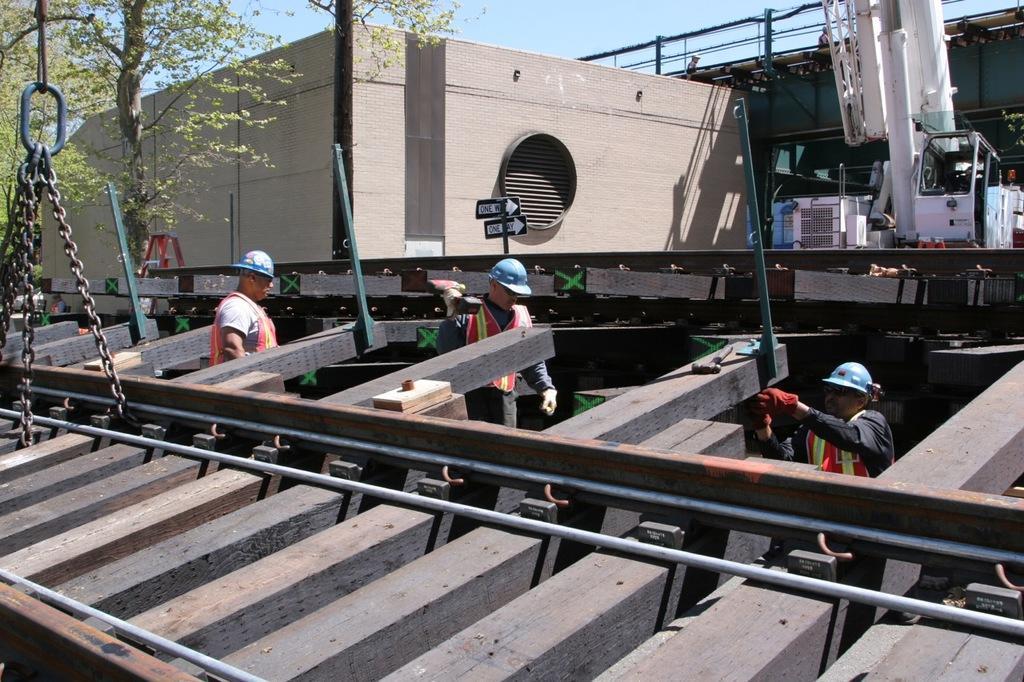How would you summarize this image in a sentence or two? Here we can see a railway track, chains, poles, boards, and three persons. There are trees, building, and objects. In the background there is sky. 